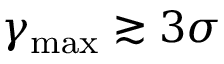<formula> <loc_0><loc_0><loc_500><loc_500>\gamma _ { \max } \gtrsim 3 \sigma</formula> 